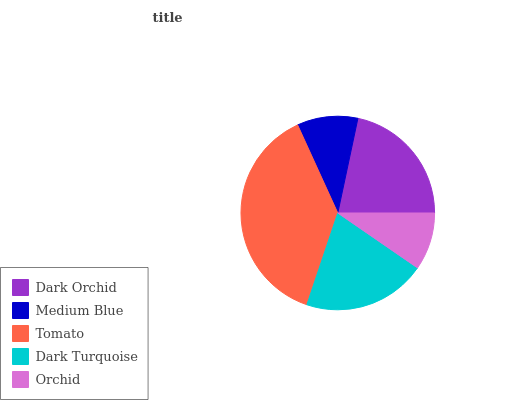Is Orchid the minimum?
Answer yes or no. Yes. Is Tomato the maximum?
Answer yes or no. Yes. Is Medium Blue the minimum?
Answer yes or no. No. Is Medium Blue the maximum?
Answer yes or no. No. Is Dark Orchid greater than Medium Blue?
Answer yes or no. Yes. Is Medium Blue less than Dark Orchid?
Answer yes or no. Yes. Is Medium Blue greater than Dark Orchid?
Answer yes or no. No. Is Dark Orchid less than Medium Blue?
Answer yes or no. No. Is Dark Turquoise the high median?
Answer yes or no. Yes. Is Dark Turquoise the low median?
Answer yes or no. Yes. Is Medium Blue the high median?
Answer yes or no. No. Is Orchid the low median?
Answer yes or no. No. 